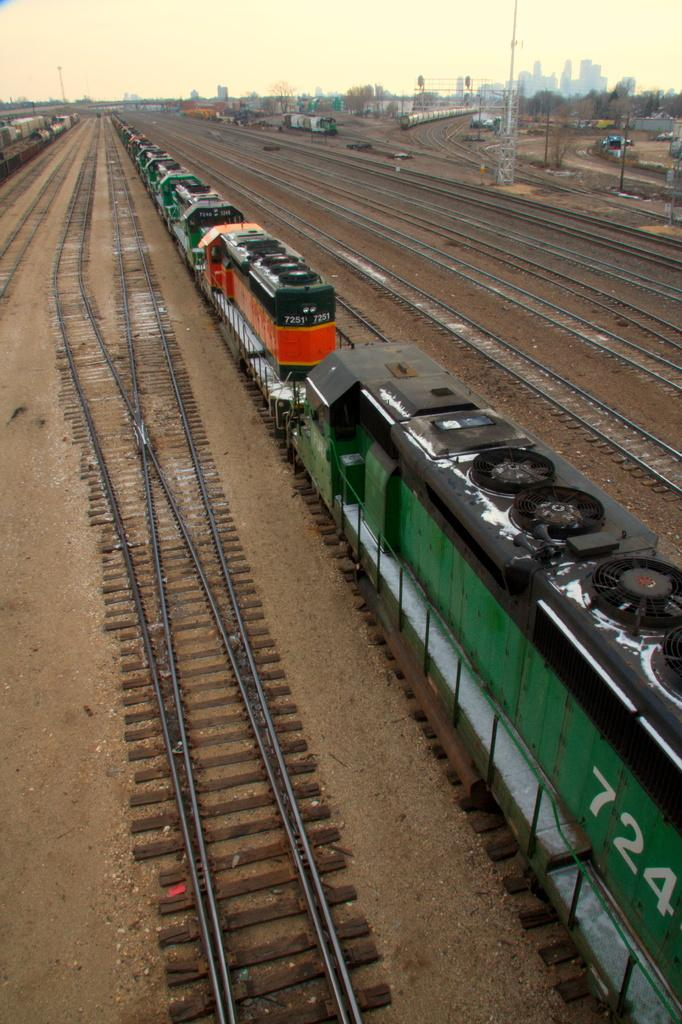What is the main subject in the center of the image? There is a train in the center of the image. What is the train traveling on? The train is traveling on railway tracks. What can be seen in the background of the image? There are buildings and poles in the background of the image. What is visible above the buildings and poles? The sky is visible in the background of the image. Can you see a quiver of arrows on the train in the image? No, there is no quiver of arrows present on the train in the image. Can you see a body of water in the image? No, there is no body of water present in the image. Can you see a mint plant growing near the train in the image? No, there is visible mint plant is present in the image. 